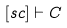<formula> <loc_0><loc_0><loc_500><loc_500>[ s c ] \vdash C</formula> 